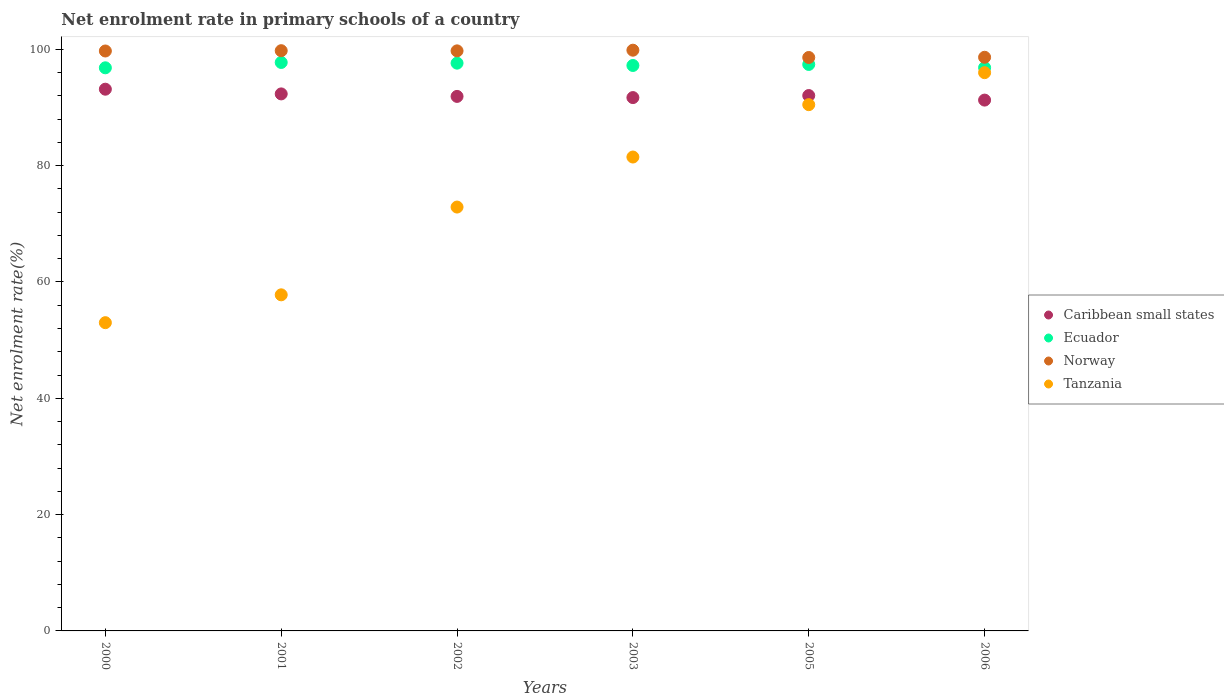What is the net enrolment rate in primary schools in Norway in 2002?
Your answer should be very brief. 99.74. Across all years, what is the maximum net enrolment rate in primary schools in Tanzania?
Keep it short and to the point. 95.99. Across all years, what is the minimum net enrolment rate in primary schools in Norway?
Make the answer very short. 98.6. In which year was the net enrolment rate in primary schools in Ecuador minimum?
Your answer should be very brief. 2000. What is the total net enrolment rate in primary schools in Caribbean small states in the graph?
Ensure brevity in your answer.  552.44. What is the difference between the net enrolment rate in primary schools in Caribbean small states in 2002 and that in 2006?
Provide a short and direct response. 0.63. What is the difference between the net enrolment rate in primary schools in Caribbean small states in 2003 and the net enrolment rate in primary schools in Tanzania in 2001?
Offer a very short reply. 33.92. What is the average net enrolment rate in primary schools in Ecuador per year?
Make the answer very short. 97.28. In the year 2000, what is the difference between the net enrolment rate in primary schools in Caribbean small states and net enrolment rate in primary schools in Ecuador?
Offer a terse response. -3.68. In how many years, is the net enrolment rate in primary schools in Tanzania greater than 92 %?
Provide a succinct answer. 1. What is the ratio of the net enrolment rate in primary schools in Ecuador in 2002 to that in 2006?
Your answer should be compact. 1.01. What is the difference between the highest and the second highest net enrolment rate in primary schools in Caribbean small states?
Offer a terse response. 0.81. What is the difference between the highest and the lowest net enrolment rate in primary schools in Caribbean small states?
Provide a succinct answer. 1.87. Is the sum of the net enrolment rate in primary schools in Caribbean small states in 2003 and 2006 greater than the maximum net enrolment rate in primary schools in Norway across all years?
Give a very brief answer. Yes. Is it the case that in every year, the sum of the net enrolment rate in primary schools in Ecuador and net enrolment rate in primary schools in Tanzania  is greater than the net enrolment rate in primary schools in Caribbean small states?
Offer a terse response. Yes. Does the net enrolment rate in primary schools in Norway monotonically increase over the years?
Provide a succinct answer. No. Is the net enrolment rate in primary schools in Tanzania strictly greater than the net enrolment rate in primary schools in Caribbean small states over the years?
Provide a short and direct response. No. How many years are there in the graph?
Provide a short and direct response. 6. Does the graph contain any zero values?
Give a very brief answer. No. Where does the legend appear in the graph?
Your answer should be compact. Center right. How many legend labels are there?
Keep it short and to the point. 4. What is the title of the graph?
Ensure brevity in your answer.  Net enrolment rate in primary schools of a country. Does "St. Vincent and the Grenadines" appear as one of the legend labels in the graph?
Your response must be concise. No. What is the label or title of the Y-axis?
Offer a terse response. Net enrolment rate(%). What is the Net enrolment rate(%) in Caribbean small states in 2000?
Provide a short and direct response. 93.15. What is the Net enrolment rate(%) of Ecuador in 2000?
Provide a succinct answer. 96.83. What is the Net enrolment rate(%) of Norway in 2000?
Offer a very short reply. 99.72. What is the Net enrolment rate(%) in Tanzania in 2000?
Your answer should be very brief. 53. What is the Net enrolment rate(%) in Caribbean small states in 2001?
Ensure brevity in your answer.  92.34. What is the Net enrolment rate(%) in Ecuador in 2001?
Provide a succinct answer. 97.75. What is the Net enrolment rate(%) of Norway in 2001?
Offer a terse response. 99.77. What is the Net enrolment rate(%) in Tanzania in 2001?
Ensure brevity in your answer.  57.79. What is the Net enrolment rate(%) in Caribbean small states in 2002?
Keep it short and to the point. 91.91. What is the Net enrolment rate(%) in Ecuador in 2002?
Your answer should be compact. 97.63. What is the Net enrolment rate(%) in Norway in 2002?
Offer a very short reply. 99.74. What is the Net enrolment rate(%) in Tanzania in 2002?
Offer a terse response. 72.88. What is the Net enrolment rate(%) in Caribbean small states in 2003?
Keep it short and to the point. 91.71. What is the Net enrolment rate(%) of Ecuador in 2003?
Offer a terse response. 97.23. What is the Net enrolment rate(%) of Norway in 2003?
Ensure brevity in your answer.  99.86. What is the Net enrolment rate(%) of Tanzania in 2003?
Offer a terse response. 81.49. What is the Net enrolment rate(%) in Caribbean small states in 2005?
Offer a very short reply. 92.06. What is the Net enrolment rate(%) in Ecuador in 2005?
Your response must be concise. 97.41. What is the Net enrolment rate(%) of Norway in 2005?
Your answer should be very brief. 98.6. What is the Net enrolment rate(%) in Tanzania in 2005?
Ensure brevity in your answer.  90.49. What is the Net enrolment rate(%) in Caribbean small states in 2006?
Your response must be concise. 91.28. What is the Net enrolment rate(%) of Ecuador in 2006?
Keep it short and to the point. 96.86. What is the Net enrolment rate(%) in Norway in 2006?
Give a very brief answer. 98.64. What is the Net enrolment rate(%) of Tanzania in 2006?
Your answer should be compact. 95.99. Across all years, what is the maximum Net enrolment rate(%) of Caribbean small states?
Give a very brief answer. 93.15. Across all years, what is the maximum Net enrolment rate(%) in Ecuador?
Offer a very short reply. 97.75. Across all years, what is the maximum Net enrolment rate(%) in Norway?
Provide a short and direct response. 99.86. Across all years, what is the maximum Net enrolment rate(%) of Tanzania?
Your response must be concise. 95.99. Across all years, what is the minimum Net enrolment rate(%) of Caribbean small states?
Provide a short and direct response. 91.28. Across all years, what is the minimum Net enrolment rate(%) in Ecuador?
Offer a terse response. 96.83. Across all years, what is the minimum Net enrolment rate(%) of Norway?
Ensure brevity in your answer.  98.6. Across all years, what is the minimum Net enrolment rate(%) in Tanzania?
Offer a very short reply. 53. What is the total Net enrolment rate(%) of Caribbean small states in the graph?
Make the answer very short. 552.44. What is the total Net enrolment rate(%) in Ecuador in the graph?
Your answer should be compact. 583.69. What is the total Net enrolment rate(%) in Norway in the graph?
Your answer should be very brief. 596.33. What is the total Net enrolment rate(%) in Tanzania in the graph?
Give a very brief answer. 451.65. What is the difference between the Net enrolment rate(%) of Caribbean small states in 2000 and that in 2001?
Offer a very short reply. 0.81. What is the difference between the Net enrolment rate(%) of Ecuador in 2000 and that in 2001?
Ensure brevity in your answer.  -0.92. What is the difference between the Net enrolment rate(%) of Norway in 2000 and that in 2001?
Your answer should be very brief. -0.05. What is the difference between the Net enrolment rate(%) in Tanzania in 2000 and that in 2001?
Offer a terse response. -4.79. What is the difference between the Net enrolment rate(%) of Caribbean small states in 2000 and that in 2002?
Make the answer very short. 1.24. What is the difference between the Net enrolment rate(%) in Ecuador in 2000 and that in 2002?
Ensure brevity in your answer.  -0.8. What is the difference between the Net enrolment rate(%) in Norway in 2000 and that in 2002?
Your answer should be very brief. -0.02. What is the difference between the Net enrolment rate(%) in Tanzania in 2000 and that in 2002?
Give a very brief answer. -19.88. What is the difference between the Net enrolment rate(%) of Caribbean small states in 2000 and that in 2003?
Offer a terse response. 1.44. What is the difference between the Net enrolment rate(%) in Ecuador in 2000 and that in 2003?
Offer a terse response. -0.4. What is the difference between the Net enrolment rate(%) in Norway in 2000 and that in 2003?
Make the answer very short. -0.14. What is the difference between the Net enrolment rate(%) in Tanzania in 2000 and that in 2003?
Offer a very short reply. -28.48. What is the difference between the Net enrolment rate(%) in Caribbean small states in 2000 and that in 2005?
Provide a short and direct response. 1.09. What is the difference between the Net enrolment rate(%) in Ecuador in 2000 and that in 2005?
Your answer should be very brief. -0.58. What is the difference between the Net enrolment rate(%) in Norway in 2000 and that in 2005?
Keep it short and to the point. 1.12. What is the difference between the Net enrolment rate(%) of Tanzania in 2000 and that in 2005?
Your answer should be compact. -37.49. What is the difference between the Net enrolment rate(%) of Caribbean small states in 2000 and that in 2006?
Offer a very short reply. 1.87. What is the difference between the Net enrolment rate(%) in Ecuador in 2000 and that in 2006?
Ensure brevity in your answer.  -0.03. What is the difference between the Net enrolment rate(%) in Norway in 2000 and that in 2006?
Your answer should be very brief. 1.08. What is the difference between the Net enrolment rate(%) in Tanzania in 2000 and that in 2006?
Provide a succinct answer. -42.99. What is the difference between the Net enrolment rate(%) in Caribbean small states in 2001 and that in 2002?
Ensure brevity in your answer.  0.43. What is the difference between the Net enrolment rate(%) of Ecuador in 2001 and that in 2002?
Ensure brevity in your answer.  0.12. What is the difference between the Net enrolment rate(%) in Norway in 2001 and that in 2002?
Your answer should be compact. 0.03. What is the difference between the Net enrolment rate(%) in Tanzania in 2001 and that in 2002?
Make the answer very short. -15.09. What is the difference between the Net enrolment rate(%) of Caribbean small states in 2001 and that in 2003?
Make the answer very short. 0.63. What is the difference between the Net enrolment rate(%) of Ecuador in 2001 and that in 2003?
Offer a terse response. 0.52. What is the difference between the Net enrolment rate(%) in Norway in 2001 and that in 2003?
Keep it short and to the point. -0.09. What is the difference between the Net enrolment rate(%) in Tanzania in 2001 and that in 2003?
Provide a short and direct response. -23.69. What is the difference between the Net enrolment rate(%) of Caribbean small states in 2001 and that in 2005?
Give a very brief answer. 0.28. What is the difference between the Net enrolment rate(%) of Ecuador in 2001 and that in 2005?
Ensure brevity in your answer.  0.34. What is the difference between the Net enrolment rate(%) in Norway in 2001 and that in 2005?
Your response must be concise. 1.17. What is the difference between the Net enrolment rate(%) of Tanzania in 2001 and that in 2005?
Keep it short and to the point. -32.7. What is the difference between the Net enrolment rate(%) in Caribbean small states in 2001 and that in 2006?
Offer a very short reply. 1.06. What is the difference between the Net enrolment rate(%) of Ecuador in 2001 and that in 2006?
Your answer should be very brief. 0.89. What is the difference between the Net enrolment rate(%) in Norway in 2001 and that in 2006?
Keep it short and to the point. 1.13. What is the difference between the Net enrolment rate(%) of Tanzania in 2001 and that in 2006?
Your response must be concise. -38.2. What is the difference between the Net enrolment rate(%) of Caribbean small states in 2002 and that in 2003?
Offer a terse response. 0.2. What is the difference between the Net enrolment rate(%) of Ecuador in 2002 and that in 2003?
Ensure brevity in your answer.  0.4. What is the difference between the Net enrolment rate(%) of Norway in 2002 and that in 2003?
Give a very brief answer. -0.11. What is the difference between the Net enrolment rate(%) in Tanzania in 2002 and that in 2003?
Ensure brevity in your answer.  -8.6. What is the difference between the Net enrolment rate(%) of Caribbean small states in 2002 and that in 2005?
Make the answer very short. -0.15. What is the difference between the Net enrolment rate(%) of Ecuador in 2002 and that in 2005?
Keep it short and to the point. 0.22. What is the difference between the Net enrolment rate(%) of Norway in 2002 and that in 2005?
Your answer should be very brief. 1.14. What is the difference between the Net enrolment rate(%) of Tanzania in 2002 and that in 2005?
Offer a very short reply. -17.61. What is the difference between the Net enrolment rate(%) of Caribbean small states in 2002 and that in 2006?
Offer a terse response. 0.63. What is the difference between the Net enrolment rate(%) of Ecuador in 2002 and that in 2006?
Offer a very short reply. 0.77. What is the difference between the Net enrolment rate(%) of Norway in 2002 and that in 2006?
Give a very brief answer. 1.1. What is the difference between the Net enrolment rate(%) in Tanzania in 2002 and that in 2006?
Provide a succinct answer. -23.11. What is the difference between the Net enrolment rate(%) of Caribbean small states in 2003 and that in 2005?
Provide a short and direct response. -0.35. What is the difference between the Net enrolment rate(%) in Ecuador in 2003 and that in 2005?
Your response must be concise. -0.18. What is the difference between the Net enrolment rate(%) in Norway in 2003 and that in 2005?
Your response must be concise. 1.25. What is the difference between the Net enrolment rate(%) in Tanzania in 2003 and that in 2005?
Provide a short and direct response. -9. What is the difference between the Net enrolment rate(%) of Caribbean small states in 2003 and that in 2006?
Ensure brevity in your answer.  0.43. What is the difference between the Net enrolment rate(%) of Ecuador in 2003 and that in 2006?
Ensure brevity in your answer.  0.37. What is the difference between the Net enrolment rate(%) in Norway in 2003 and that in 2006?
Keep it short and to the point. 1.22. What is the difference between the Net enrolment rate(%) in Tanzania in 2003 and that in 2006?
Offer a terse response. -14.51. What is the difference between the Net enrolment rate(%) in Caribbean small states in 2005 and that in 2006?
Provide a short and direct response. 0.78. What is the difference between the Net enrolment rate(%) of Ecuador in 2005 and that in 2006?
Provide a short and direct response. 0.55. What is the difference between the Net enrolment rate(%) of Norway in 2005 and that in 2006?
Keep it short and to the point. -0.04. What is the difference between the Net enrolment rate(%) in Tanzania in 2005 and that in 2006?
Your answer should be compact. -5.5. What is the difference between the Net enrolment rate(%) of Caribbean small states in 2000 and the Net enrolment rate(%) of Ecuador in 2001?
Your answer should be compact. -4.6. What is the difference between the Net enrolment rate(%) in Caribbean small states in 2000 and the Net enrolment rate(%) in Norway in 2001?
Make the answer very short. -6.62. What is the difference between the Net enrolment rate(%) in Caribbean small states in 2000 and the Net enrolment rate(%) in Tanzania in 2001?
Make the answer very short. 35.36. What is the difference between the Net enrolment rate(%) in Ecuador in 2000 and the Net enrolment rate(%) in Norway in 2001?
Offer a terse response. -2.94. What is the difference between the Net enrolment rate(%) in Ecuador in 2000 and the Net enrolment rate(%) in Tanzania in 2001?
Offer a very short reply. 39.04. What is the difference between the Net enrolment rate(%) of Norway in 2000 and the Net enrolment rate(%) of Tanzania in 2001?
Offer a very short reply. 41.93. What is the difference between the Net enrolment rate(%) in Caribbean small states in 2000 and the Net enrolment rate(%) in Ecuador in 2002?
Provide a short and direct response. -4.48. What is the difference between the Net enrolment rate(%) of Caribbean small states in 2000 and the Net enrolment rate(%) of Norway in 2002?
Offer a terse response. -6.59. What is the difference between the Net enrolment rate(%) of Caribbean small states in 2000 and the Net enrolment rate(%) of Tanzania in 2002?
Ensure brevity in your answer.  20.27. What is the difference between the Net enrolment rate(%) in Ecuador in 2000 and the Net enrolment rate(%) in Norway in 2002?
Offer a terse response. -2.91. What is the difference between the Net enrolment rate(%) of Ecuador in 2000 and the Net enrolment rate(%) of Tanzania in 2002?
Ensure brevity in your answer.  23.94. What is the difference between the Net enrolment rate(%) of Norway in 2000 and the Net enrolment rate(%) of Tanzania in 2002?
Ensure brevity in your answer.  26.84. What is the difference between the Net enrolment rate(%) of Caribbean small states in 2000 and the Net enrolment rate(%) of Ecuador in 2003?
Your answer should be very brief. -4.08. What is the difference between the Net enrolment rate(%) of Caribbean small states in 2000 and the Net enrolment rate(%) of Norway in 2003?
Make the answer very short. -6.71. What is the difference between the Net enrolment rate(%) of Caribbean small states in 2000 and the Net enrolment rate(%) of Tanzania in 2003?
Offer a very short reply. 11.66. What is the difference between the Net enrolment rate(%) in Ecuador in 2000 and the Net enrolment rate(%) in Norway in 2003?
Give a very brief answer. -3.03. What is the difference between the Net enrolment rate(%) in Ecuador in 2000 and the Net enrolment rate(%) in Tanzania in 2003?
Make the answer very short. 15.34. What is the difference between the Net enrolment rate(%) of Norway in 2000 and the Net enrolment rate(%) of Tanzania in 2003?
Make the answer very short. 18.23. What is the difference between the Net enrolment rate(%) of Caribbean small states in 2000 and the Net enrolment rate(%) of Ecuador in 2005?
Your answer should be very brief. -4.26. What is the difference between the Net enrolment rate(%) in Caribbean small states in 2000 and the Net enrolment rate(%) in Norway in 2005?
Offer a very short reply. -5.45. What is the difference between the Net enrolment rate(%) of Caribbean small states in 2000 and the Net enrolment rate(%) of Tanzania in 2005?
Make the answer very short. 2.66. What is the difference between the Net enrolment rate(%) of Ecuador in 2000 and the Net enrolment rate(%) of Norway in 2005?
Offer a terse response. -1.77. What is the difference between the Net enrolment rate(%) in Ecuador in 2000 and the Net enrolment rate(%) in Tanzania in 2005?
Provide a succinct answer. 6.34. What is the difference between the Net enrolment rate(%) of Norway in 2000 and the Net enrolment rate(%) of Tanzania in 2005?
Provide a short and direct response. 9.23. What is the difference between the Net enrolment rate(%) of Caribbean small states in 2000 and the Net enrolment rate(%) of Ecuador in 2006?
Keep it short and to the point. -3.71. What is the difference between the Net enrolment rate(%) of Caribbean small states in 2000 and the Net enrolment rate(%) of Norway in 2006?
Give a very brief answer. -5.49. What is the difference between the Net enrolment rate(%) in Caribbean small states in 2000 and the Net enrolment rate(%) in Tanzania in 2006?
Offer a terse response. -2.84. What is the difference between the Net enrolment rate(%) of Ecuador in 2000 and the Net enrolment rate(%) of Norway in 2006?
Keep it short and to the point. -1.81. What is the difference between the Net enrolment rate(%) of Ecuador in 2000 and the Net enrolment rate(%) of Tanzania in 2006?
Provide a succinct answer. 0.83. What is the difference between the Net enrolment rate(%) of Norway in 2000 and the Net enrolment rate(%) of Tanzania in 2006?
Your answer should be compact. 3.73. What is the difference between the Net enrolment rate(%) of Caribbean small states in 2001 and the Net enrolment rate(%) of Ecuador in 2002?
Ensure brevity in your answer.  -5.29. What is the difference between the Net enrolment rate(%) of Caribbean small states in 2001 and the Net enrolment rate(%) of Norway in 2002?
Your answer should be very brief. -7.4. What is the difference between the Net enrolment rate(%) in Caribbean small states in 2001 and the Net enrolment rate(%) in Tanzania in 2002?
Offer a very short reply. 19.46. What is the difference between the Net enrolment rate(%) of Ecuador in 2001 and the Net enrolment rate(%) of Norway in 2002?
Your answer should be compact. -2. What is the difference between the Net enrolment rate(%) of Ecuador in 2001 and the Net enrolment rate(%) of Tanzania in 2002?
Your answer should be compact. 24.86. What is the difference between the Net enrolment rate(%) in Norway in 2001 and the Net enrolment rate(%) in Tanzania in 2002?
Your answer should be very brief. 26.89. What is the difference between the Net enrolment rate(%) in Caribbean small states in 2001 and the Net enrolment rate(%) in Ecuador in 2003?
Your answer should be very brief. -4.89. What is the difference between the Net enrolment rate(%) of Caribbean small states in 2001 and the Net enrolment rate(%) of Norway in 2003?
Ensure brevity in your answer.  -7.52. What is the difference between the Net enrolment rate(%) of Caribbean small states in 2001 and the Net enrolment rate(%) of Tanzania in 2003?
Your response must be concise. 10.85. What is the difference between the Net enrolment rate(%) of Ecuador in 2001 and the Net enrolment rate(%) of Norway in 2003?
Keep it short and to the point. -2.11. What is the difference between the Net enrolment rate(%) in Ecuador in 2001 and the Net enrolment rate(%) in Tanzania in 2003?
Ensure brevity in your answer.  16.26. What is the difference between the Net enrolment rate(%) of Norway in 2001 and the Net enrolment rate(%) of Tanzania in 2003?
Make the answer very short. 18.28. What is the difference between the Net enrolment rate(%) in Caribbean small states in 2001 and the Net enrolment rate(%) in Ecuador in 2005?
Offer a terse response. -5.06. What is the difference between the Net enrolment rate(%) in Caribbean small states in 2001 and the Net enrolment rate(%) in Norway in 2005?
Offer a terse response. -6.26. What is the difference between the Net enrolment rate(%) in Caribbean small states in 2001 and the Net enrolment rate(%) in Tanzania in 2005?
Make the answer very short. 1.85. What is the difference between the Net enrolment rate(%) of Ecuador in 2001 and the Net enrolment rate(%) of Norway in 2005?
Offer a terse response. -0.86. What is the difference between the Net enrolment rate(%) in Ecuador in 2001 and the Net enrolment rate(%) in Tanzania in 2005?
Your response must be concise. 7.26. What is the difference between the Net enrolment rate(%) in Norway in 2001 and the Net enrolment rate(%) in Tanzania in 2005?
Your answer should be very brief. 9.28. What is the difference between the Net enrolment rate(%) of Caribbean small states in 2001 and the Net enrolment rate(%) of Ecuador in 2006?
Ensure brevity in your answer.  -4.52. What is the difference between the Net enrolment rate(%) of Caribbean small states in 2001 and the Net enrolment rate(%) of Norway in 2006?
Your response must be concise. -6.3. What is the difference between the Net enrolment rate(%) in Caribbean small states in 2001 and the Net enrolment rate(%) in Tanzania in 2006?
Give a very brief answer. -3.65. What is the difference between the Net enrolment rate(%) in Ecuador in 2001 and the Net enrolment rate(%) in Norway in 2006?
Ensure brevity in your answer.  -0.89. What is the difference between the Net enrolment rate(%) in Ecuador in 2001 and the Net enrolment rate(%) in Tanzania in 2006?
Make the answer very short. 1.75. What is the difference between the Net enrolment rate(%) in Norway in 2001 and the Net enrolment rate(%) in Tanzania in 2006?
Give a very brief answer. 3.78. What is the difference between the Net enrolment rate(%) in Caribbean small states in 2002 and the Net enrolment rate(%) in Ecuador in 2003?
Keep it short and to the point. -5.32. What is the difference between the Net enrolment rate(%) of Caribbean small states in 2002 and the Net enrolment rate(%) of Norway in 2003?
Your response must be concise. -7.95. What is the difference between the Net enrolment rate(%) in Caribbean small states in 2002 and the Net enrolment rate(%) in Tanzania in 2003?
Provide a short and direct response. 10.42. What is the difference between the Net enrolment rate(%) of Ecuador in 2002 and the Net enrolment rate(%) of Norway in 2003?
Offer a very short reply. -2.23. What is the difference between the Net enrolment rate(%) of Ecuador in 2002 and the Net enrolment rate(%) of Tanzania in 2003?
Give a very brief answer. 16.14. What is the difference between the Net enrolment rate(%) of Norway in 2002 and the Net enrolment rate(%) of Tanzania in 2003?
Provide a short and direct response. 18.26. What is the difference between the Net enrolment rate(%) of Caribbean small states in 2002 and the Net enrolment rate(%) of Ecuador in 2005?
Your answer should be compact. -5.49. What is the difference between the Net enrolment rate(%) in Caribbean small states in 2002 and the Net enrolment rate(%) in Norway in 2005?
Provide a succinct answer. -6.69. What is the difference between the Net enrolment rate(%) in Caribbean small states in 2002 and the Net enrolment rate(%) in Tanzania in 2005?
Provide a succinct answer. 1.42. What is the difference between the Net enrolment rate(%) of Ecuador in 2002 and the Net enrolment rate(%) of Norway in 2005?
Offer a very short reply. -0.97. What is the difference between the Net enrolment rate(%) of Ecuador in 2002 and the Net enrolment rate(%) of Tanzania in 2005?
Make the answer very short. 7.14. What is the difference between the Net enrolment rate(%) of Norway in 2002 and the Net enrolment rate(%) of Tanzania in 2005?
Your answer should be very brief. 9.25. What is the difference between the Net enrolment rate(%) in Caribbean small states in 2002 and the Net enrolment rate(%) in Ecuador in 2006?
Provide a short and direct response. -4.95. What is the difference between the Net enrolment rate(%) in Caribbean small states in 2002 and the Net enrolment rate(%) in Norway in 2006?
Make the answer very short. -6.73. What is the difference between the Net enrolment rate(%) in Caribbean small states in 2002 and the Net enrolment rate(%) in Tanzania in 2006?
Ensure brevity in your answer.  -4.08. What is the difference between the Net enrolment rate(%) in Ecuador in 2002 and the Net enrolment rate(%) in Norway in 2006?
Provide a succinct answer. -1.01. What is the difference between the Net enrolment rate(%) in Ecuador in 2002 and the Net enrolment rate(%) in Tanzania in 2006?
Your response must be concise. 1.64. What is the difference between the Net enrolment rate(%) of Norway in 2002 and the Net enrolment rate(%) of Tanzania in 2006?
Provide a succinct answer. 3.75. What is the difference between the Net enrolment rate(%) of Caribbean small states in 2003 and the Net enrolment rate(%) of Ecuador in 2005?
Ensure brevity in your answer.  -5.7. What is the difference between the Net enrolment rate(%) in Caribbean small states in 2003 and the Net enrolment rate(%) in Norway in 2005?
Provide a succinct answer. -6.89. What is the difference between the Net enrolment rate(%) in Caribbean small states in 2003 and the Net enrolment rate(%) in Tanzania in 2005?
Ensure brevity in your answer.  1.22. What is the difference between the Net enrolment rate(%) of Ecuador in 2003 and the Net enrolment rate(%) of Norway in 2005?
Give a very brief answer. -1.37. What is the difference between the Net enrolment rate(%) of Ecuador in 2003 and the Net enrolment rate(%) of Tanzania in 2005?
Offer a terse response. 6.74. What is the difference between the Net enrolment rate(%) of Norway in 2003 and the Net enrolment rate(%) of Tanzania in 2005?
Provide a short and direct response. 9.36. What is the difference between the Net enrolment rate(%) in Caribbean small states in 2003 and the Net enrolment rate(%) in Ecuador in 2006?
Provide a succinct answer. -5.15. What is the difference between the Net enrolment rate(%) of Caribbean small states in 2003 and the Net enrolment rate(%) of Norway in 2006?
Offer a very short reply. -6.93. What is the difference between the Net enrolment rate(%) of Caribbean small states in 2003 and the Net enrolment rate(%) of Tanzania in 2006?
Your answer should be very brief. -4.28. What is the difference between the Net enrolment rate(%) of Ecuador in 2003 and the Net enrolment rate(%) of Norway in 2006?
Ensure brevity in your answer.  -1.41. What is the difference between the Net enrolment rate(%) of Ecuador in 2003 and the Net enrolment rate(%) of Tanzania in 2006?
Provide a succinct answer. 1.24. What is the difference between the Net enrolment rate(%) of Norway in 2003 and the Net enrolment rate(%) of Tanzania in 2006?
Your answer should be compact. 3.86. What is the difference between the Net enrolment rate(%) in Caribbean small states in 2005 and the Net enrolment rate(%) in Ecuador in 2006?
Your answer should be compact. -4.8. What is the difference between the Net enrolment rate(%) in Caribbean small states in 2005 and the Net enrolment rate(%) in Norway in 2006?
Your answer should be very brief. -6.58. What is the difference between the Net enrolment rate(%) in Caribbean small states in 2005 and the Net enrolment rate(%) in Tanzania in 2006?
Provide a short and direct response. -3.93. What is the difference between the Net enrolment rate(%) of Ecuador in 2005 and the Net enrolment rate(%) of Norway in 2006?
Offer a very short reply. -1.23. What is the difference between the Net enrolment rate(%) of Ecuador in 2005 and the Net enrolment rate(%) of Tanzania in 2006?
Provide a succinct answer. 1.41. What is the difference between the Net enrolment rate(%) of Norway in 2005 and the Net enrolment rate(%) of Tanzania in 2006?
Keep it short and to the point. 2.61. What is the average Net enrolment rate(%) in Caribbean small states per year?
Make the answer very short. 92.07. What is the average Net enrolment rate(%) of Ecuador per year?
Your response must be concise. 97.28. What is the average Net enrolment rate(%) of Norway per year?
Provide a short and direct response. 99.39. What is the average Net enrolment rate(%) of Tanzania per year?
Offer a terse response. 75.27. In the year 2000, what is the difference between the Net enrolment rate(%) in Caribbean small states and Net enrolment rate(%) in Ecuador?
Your answer should be very brief. -3.68. In the year 2000, what is the difference between the Net enrolment rate(%) of Caribbean small states and Net enrolment rate(%) of Norway?
Offer a very short reply. -6.57. In the year 2000, what is the difference between the Net enrolment rate(%) in Caribbean small states and Net enrolment rate(%) in Tanzania?
Make the answer very short. 40.15. In the year 2000, what is the difference between the Net enrolment rate(%) in Ecuador and Net enrolment rate(%) in Norway?
Your response must be concise. -2.89. In the year 2000, what is the difference between the Net enrolment rate(%) in Ecuador and Net enrolment rate(%) in Tanzania?
Your response must be concise. 43.82. In the year 2000, what is the difference between the Net enrolment rate(%) in Norway and Net enrolment rate(%) in Tanzania?
Your response must be concise. 46.72. In the year 2001, what is the difference between the Net enrolment rate(%) in Caribbean small states and Net enrolment rate(%) in Ecuador?
Your answer should be very brief. -5.41. In the year 2001, what is the difference between the Net enrolment rate(%) in Caribbean small states and Net enrolment rate(%) in Norway?
Give a very brief answer. -7.43. In the year 2001, what is the difference between the Net enrolment rate(%) of Caribbean small states and Net enrolment rate(%) of Tanzania?
Your answer should be very brief. 34.55. In the year 2001, what is the difference between the Net enrolment rate(%) in Ecuador and Net enrolment rate(%) in Norway?
Provide a succinct answer. -2.02. In the year 2001, what is the difference between the Net enrolment rate(%) of Ecuador and Net enrolment rate(%) of Tanzania?
Your response must be concise. 39.95. In the year 2001, what is the difference between the Net enrolment rate(%) of Norway and Net enrolment rate(%) of Tanzania?
Make the answer very short. 41.98. In the year 2002, what is the difference between the Net enrolment rate(%) of Caribbean small states and Net enrolment rate(%) of Ecuador?
Make the answer very short. -5.72. In the year 2002, what is the difference between the Net enrolment rate(%) of Caribbean small states and Net enrolment rate(%) of Norway?
Your answer should be very brief. -7.83. In the year 2002, what is the difference between the Net enrolment rate(%) of Caribbean small states and Net enrolment rate(%) of Tanzania?
Provide a short and direct response. 19.03. In the year 2002, what is the difference between the Net enrolment rate(%) of Ecuador and Net enrolment rate(%) of Norway?
Provide a short and direct response. -2.11. In the year 2002, what is the difference between the Net enrolment rate(%) of Ecuador and Net enrolment rate(%) of Tanzania?
Your answer should be very brief. 24.75. In the year 2002, what is the difference between the Net enrolment rate(%) in Norway and Net enrolment rate(%) in Tanzania?
Give a very brief answer. 26.86. In the year 2003, what is the difference between the Net enrolment rate(%) of Caribbean small states and Net enrolment rate(%) of Ecuador?
Make the answer very short. -5.52. In the year 2003, what is the difference between the Net enrolment rate(%) of Caribbean small states and Net enrolment rate(%) of Norway?
Your answer should be very brief. -8.15. In the year 2003, what is the difference between the Net enrolment rate(%) in Caribbean small states and Net enrolment rate(%) in Tanzania?
Provide a short and direct response. 10.22. In the year 2003, what is the difference between the Net enrolment rate(%) of Ecuador and Net enrolment rate(%) of Norway?
Ensure brevity in your answer.  -2.63. In the year 2003, what is the difference between the Net enrolment rate(%) in Ecuador and Net enrolment rate(%) in Tanzania?
Provide a short and direct response. 15.74. In the year 2003, what is the difference between the Net enrolment rate(%) of Norway and Net enrolment rate(%) of Tanzania?
Your answer should be compact. 18.37. In the year 2005, what is the difference between the Net enrolment rate(%) in Caribbean small states and Net enrolment rate(%) in Ecuador?
Provide a short and direct response. -5.35. In the year 2005, what is the difference between the Net enrolment rate(%) in Caribbean small states and Net enrolment rate(%) in Norway?
Your answer should be compact. -6.54. In the year 2005, what is the difference between the Net enrolment rate(%) of Caribbean small states and Net enrolment rate(%) of Tanzania?
Ensure brevity in your answer.  1.57. In the year 2005, what is the difference between the Net enrolment rate(%) in Ecuador and Net enrolment rate(%) in Norway?
Give a very brief answer. -1.2. In the year 2005, what is the difference between the Net enrolment rate(%) of Ecuador and Net enrolment rate(%) of Tanzania?
Provide a short and direct response. 6.91. In the year 2005, what is the difference between the Net enrolment rate(%) in Norway and Net enrolment rate(%) in Tanzania?
Keep it short and to the point. 8.11. In the year 2006, what is the difference between the Net enrolment rate(%) in Caribbean small states and Net enrolment rate(%) in Ecuador?
Provide a short and direct response. -5.58. In the year 2006, what is the difference between the Net enrolment rate(%) of Caribbean small states and Net enrolment rate(%) of Norway?
Offer a very short reply. -7.36. In the year 2006, what is the difference between the Net enrolment rate(%) of Caribbean small states and Net enrolment rate(%) of Tanzania?
Offer a very short reply. -4.72. In the year 2006, what is the difference between the Net enrolment rate(%) in Ecuador and Net enrolment rate(%) in Norway?
Your response must be concise. -1.78. In the year 2006, what is the difference between the Net enrolment rate(%) of Ecuador and Net enrolment rate(%) of Tanzania?
Provide a short and direct response. 0.86. In the year 2006, what is the difference between the Net enrolment rate(%) in Norway and Net enrolment rate(%) in Tanzania?
Your response must be concise. 2.65. What is the ratio of the Net enrolment rate(%) of Caribbean small states in 2000 to that in 2001?
Keep it short and to the point. 1.01. What is the ratio of the Net enrolment rate(%) in Ecuador in 2000 to that in 2001?
Your answer should be compact. 0.99. What is the ratio of the Net enrolment rate(%) in Norway in 2000 to that in 2001?
Offer a very short reply. 1. What is the ratio of the Net enrolment rate(%) of Tanzania in 2000 to that in 2001?
Provide a short and direct response. 0.92. What is the ratio of the Net enrolment rate(%) of Caribbean small states in 2000 to that in 2002?
Keep it short and to the point. 1.01. What is the ratio of the Net enrolment rate(%) in Norway in 2000 to that in 2002?
Your response must be concise. 1. What is the ratio of the Net enrolment rate(%) of Tanzania in 2000 to that in 2002?
Provide a short and direct response. 0.73. What is the ratio of the Net enrolment rate(%) of Caribbean small states in 2000 to that in 2003?
Offer a terse response. 1.02. What is the ratio of the Net enrolment rate(%) of Tanzania in 2000 to that in 2003?
Your answer should be very brief. 0.65. What is the ratio of the Net enrolment rate(%) in Caribbean small states in 2000 to that in 2005?
Ensure brevity in your answer.  1.01. What is the ratio of the Net enrolment rate(%) of Ecuador in 2000 to that in 2005?
Your response must be concise. 0.99. What is the ratio of the Net enrolment rate(%) in Norway in 2000 to that in 2005?
Offer a very short reply. 1.01. What is the ratio of the Net enrolment rate(%) in Tanzania in 2000 to that in 2005?
Ensure brevity in your answer.  0.59. What is the ratio of the Net enrolment rate(%) in Caribbean small states in 2000 to that in 2006?
Provide a short and direct response. 1.02. What is the ratio of the Net enrolment rate(%) in Norway in 2000 to that in 2006?
Make the answer very short. 1.01. What is the ratio of the Net enrolment rate(%) in Tanzania in 2000 to that in 2006?
Keep it short and to the point. 0.55. What is the ratio of the Net enrolment rate(%) of Ecuador in 2001 to that in 2002?
Give a very brief answer. 1. What is the ratio of the Net enrolment rate(%) of Norway in 2001 to that in 2002?
Make the answer very short. 1. What is the ratio of the Net enrolment rate(%) of Tanzania in 2001 to that in 2002?
Make the answer very short. 0.79. What is the ratio of the Net enrolment rate(%) of Ecuador in 2001 to that in 2003?
Keep it short and to the point. 1.01. What is the ratio of the Net enrolment rate(%) in Norway in 2001 to that in 2003?
Ensure brevity in your answer.  1. What is the ratio of the Net enrolment rate(%) in Tanzania in 2001 to that in 2003?
Offer a terse response. 0.71. What is the ratio of the Net enrolment rate(%) of Norway in 2001 to that in 2005?
Your answer should be compact. 1.01. What is the ratio of the Net enrolment rate(%) of Tanzania in 2001 to that in 2005?
Your answer should be compact. 0.64. What is the ratio of the Net enrolment rate(%) in Caribbean small states in 2001 to that in 2006?
Provide a short and direct response. 1.01. What is the ratio of the Net enrolment rate(%) of Ecuador in 2001 to that in 2006?
Provide a succinct answer. 1.01. What is the ratio of the Net enrolment rate(%) in Norway in 2001 to that in 2006?
Your answer should be compact. 1.01. What is the ratio of the Net enrolment rate(%) of Tanzania in 2001 to that in 2006?
Keep it short and to the point. 0.6. What is the ratio of the Net enrolment rate(%) in Caribbean small states in 2002 to that in 2003?
Your response must be concise. 1. What is the ratio of the Net enrolment rate(%) of Norway in 2002 to that in 2003?
Provide a succinct answer. 1. What is the ratio of the Net enrolment rate(%) in Tanzania in 2002 to that in 2003?
Offer a very short reply. 0.89. What is the ratio of the Net enrolment rate(%) of Norway in 2002 to that in 2005?
Offer a very short reply. 1.01. What is the ratio of the Net enrolment rate(%) in Tanzania in 2002 to that in 2005?
Make the answer very short. 0.81. What is the ratio of the Net enrolment rate(%) of Caribbean small states in 2002 to that in 2006?
Your answer should be compact. 1.01. What is the ratio of the Net enrolment rate(%) of Norway in 2002 to that in 2006?
Make the answer very short. 1.01. What is the ratio of the Net enrolment rate(%) in Tanzania in 2002 to that in 2006?
Keep it short and to the point. 0.76. What is the ratio of the Net enrolment rate(%) in Norway in 2003 to that in 2005?
Ensure brevity in your answer.  1.01. What is the ratio of the Net enrolment rate(%) of Tanzania in 2003 to that in 2005?
Keep it short and to the point. 0.9. What is the ratio of the Net enrolment rate(%) in Norway in 2003 to that in 2006?
Keep it short and to the point. 1.01. What is the ratio of the Net enrolment rate(%) in Tanzania in 2003 to that in 2006?
Provide a short and direct response. 0.85. What is the ratio of the Net enrolment rate(%) in Caribbean small states in 2005 to that in 2006?
Your response must be concise. 1.01. What is the ratio of the Net enrolment rate(%) in Ecuador in 2005 to that in 2006?
Your answer should be compact. 1.01. What is the ratio of the Net enrolment rate(%) of Norway in 2005 to that in 2006?
Provide a short and direct response. 1. What is the ratio of the Net enrolment rate(%) in Tanzania in 2005 to that in 2006?
Your answer should be very brief. 0.94. What is the difference between the highest and the second highest Net enrolment rate(%) in Caribbean small states?
Offer a very short reply. 0.81. What is the difference between the highest and the second highest Net enrolment rate(%) of Ecuador?
Your answer should be very brief. 0.12. What is the difference between the highest and the second highest Net enrolment rate(%) of Norway?
Keep it short and to the point. 0.09. What is the difference between the highest and the second highest Net enrolment rate(%) in Tanzania?
Provide a short and direct response. 5.5. What is the difference between the highest and the lowest Net enrolment rate(%) of Caribbean small states?
Offer a very short reply. 1.87. What is the difference between the highest and the lowest Net enrolment rate(%) of Ecuador?
Your answer should be compact. 0.92. What is the difference between the highest and the lowest Net enrolment rate(%) in Norway?
Ensure brevity in your answer.  1.25. What is the difference between the highest and the lowest Net enrolment rate(%) in Tanzania?
Offer a very short reply. 42.99. 